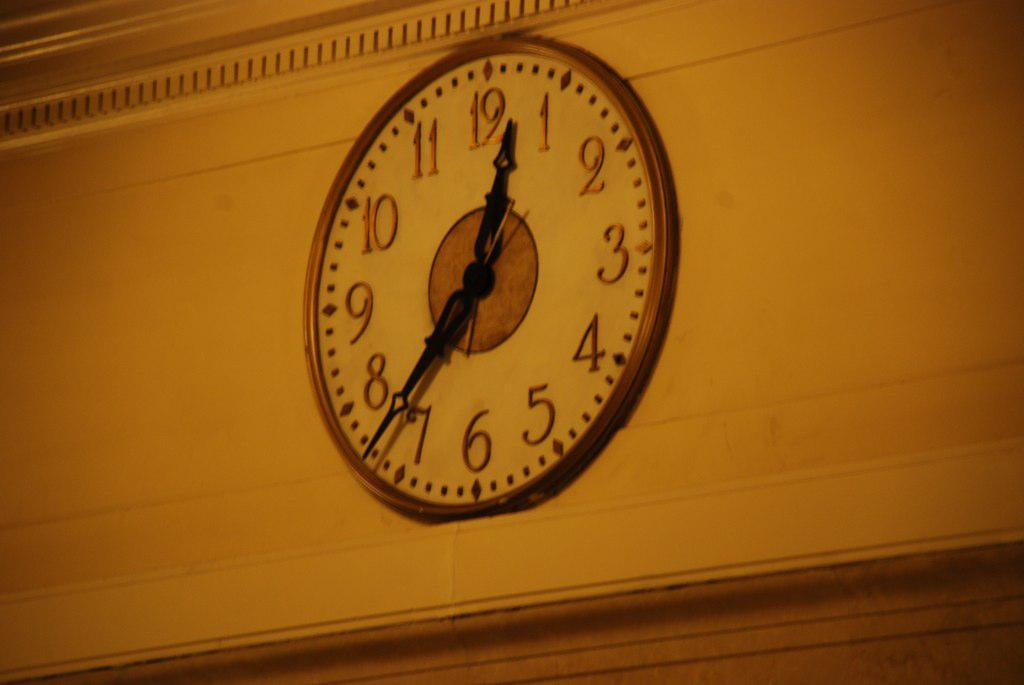What object can be seen on the wall in the image? There is a clock on the wall in the image. Can you describe the wall in the image? There is a wall in the image, but no specific details about its appearance are provided. What type of thread is used to hold the dust on the wall in the image? There is no dust or thread present in the image; it only features a clock on the wall. 